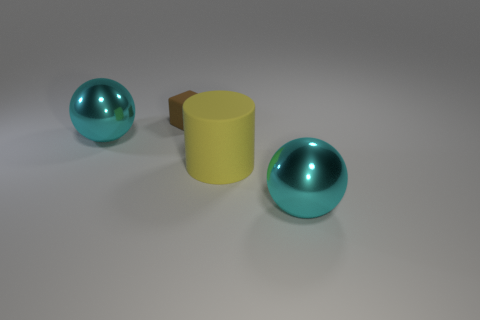How many other things are there of the same color as the tiny cube?
Provide a succinct answer. 0. How many other things are there of the same material as the small object?
Offer a very short reply. 1. There is a block; is its size the same as the matte cylinder in front of the cube?
Give a very brief answer. No. The tiny matte thing has what color?
Offer a very short reply. Brown. There is a cyan thing left of the cyan object that is in front of the cyan object to the left of the big yellow matte cylinder; what is its shape?
Offer a very short reply. Sphere. The large cyan object that is left of the large sphere in front of the large yellow rubber object is made of what material?
Your answer should be very brief. Metal. The small brown object that is the same material as the large yellow thing is what shape?
Your answer should be very brief. Cube. Is there any other thing that has the same shape as the brown object?
Offer a very short reply. No. How many cyan objects are to the right of the rubber cube?
Keep it short and to the point. 1. Are any brown blocks visible?
Provide a succinct answer. Yes. 